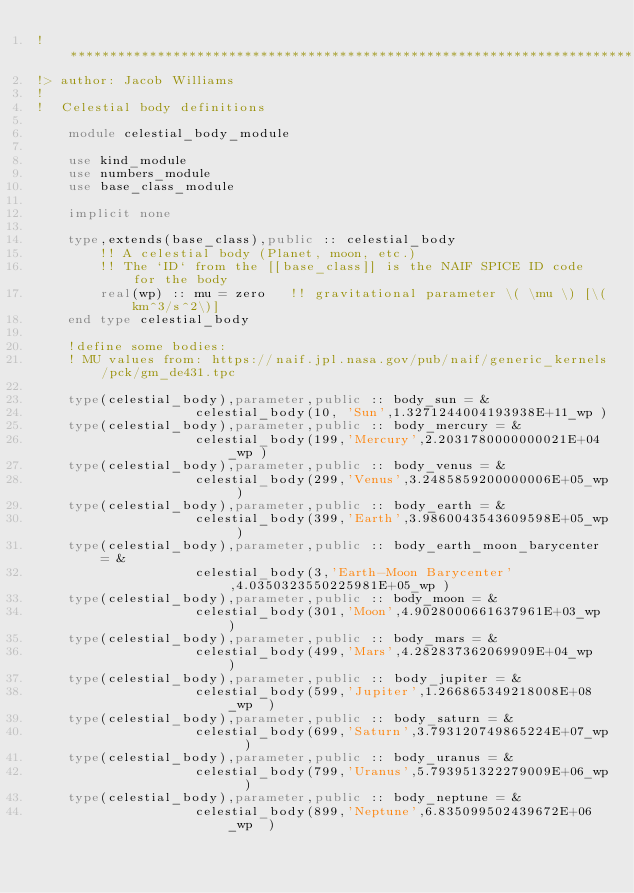Convert code to text. <code><loc_0><loc_0><loc_500><loc_500><_FORTRAN_>!*****************************************************************************************
!> author: Jacob Williams
!
!  Celestial body definitions

    module celestial_body_module

    use kind_module
    use numbers_module
    use base_class_module

    implicit none

    type,extends(base_class),public :: celestial_body
        !! A celestial body (Planet, moon, etc.)
        !! The `ID` from the [[base_class]] is the NAIF SPICE ID code for the body
        real(wp) :: mu = zero   !! gravitational parameter \( \mu \) [\(km^3/s^2\)]
    end type celestial_body

    !define some bodies:
    ! MU values from: https://naif.jpl.nasa.gov/pub/naif/generic_kernels/pck/gm_de431.tpc

    type(celestial_body),parameter,public :: body_sun = &
                    celestial_body(10, 'Sun',1.3271244004193938E+11_wp )
    type(celestial_body),parameter,public :: body_mercury = &
                    celestial_body(199,'Mercury',2.2031780000000021E+04_wp )
    type(celestial_body),parameter,public :: body_venus = &
                    celestial_body(299,'Venus',3.2485859200000006E+05_wp )
    type(celestial_body),parameter,public :: body_earth = &
                    celestial_body(399,'Earth',3.9860043543609598E+05_wp )
    type(celestial_body),parameter,public :: body_earth_moon_barycenter = &
                    celestial_body(3,'Earth-Moon Barycenter',4.0350323550225981E+05_wp )
    type(celestial_body),parameter,public :: body_moon = &
                    celestial_body(301,'Moon',4.9028000661637961E+03_wp )
    type(celestial_body),parameter,public :: body_mars = &
                    celestial_body(499,'Mars',4.282837362069909E+04_wp  )
    type(celestial_body),parameter,public :: body_jupiter = &
                    celestial_body(599,'Jupiter',1.266865349218008E+08_wp  )
    type(celestial_body),parameter,public :: body_saturn = &
                    celestial_body(699,'Saturn',3.793120749865224E+07_wp  )
    type(celestial_body),parameter,public :: body_uranus = &
                    celestial_body(799,'Uranus',5.793951322279009E+06_wp  )
    type(celestial_body),parameter,public :: body_neptune = &
                    celestial_body(899,'Neptune',6.835099502439672E+06_wp  )</code> 